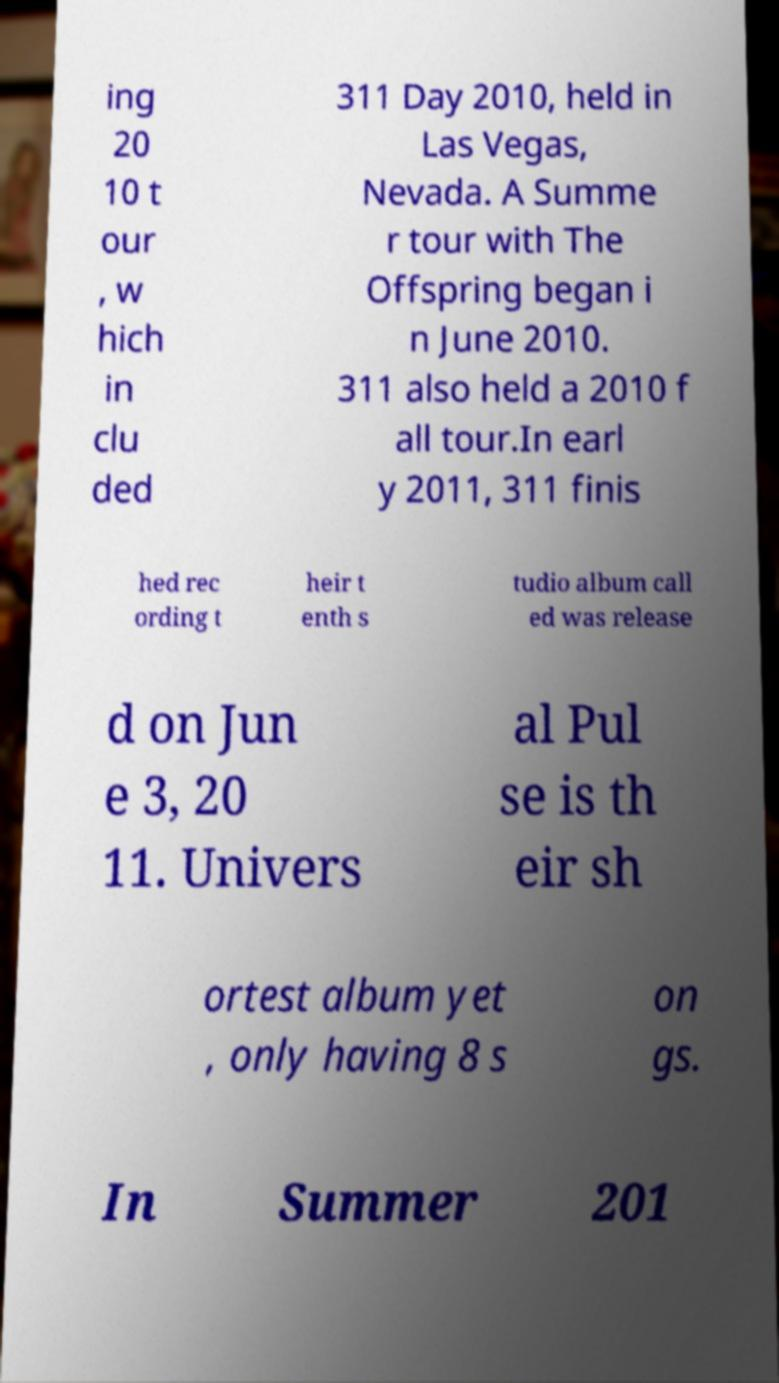Could you extract and type out the text from this image? ing 20 10 t our , w hich in clu ded 311 Day 2010, held in Las Vegas, Nevada. A Summe r tour with The Offspring began i n June 2010. 311 also held a 2010 f all tour.In earl y 2011, 311 finis hed rec ording t heir t enth s tudio album call ed was release d on Jun e 3, 20 11. Univers al Pul se is th eir sh ortest album yet , only having 8 s on gs. In Summer 201 